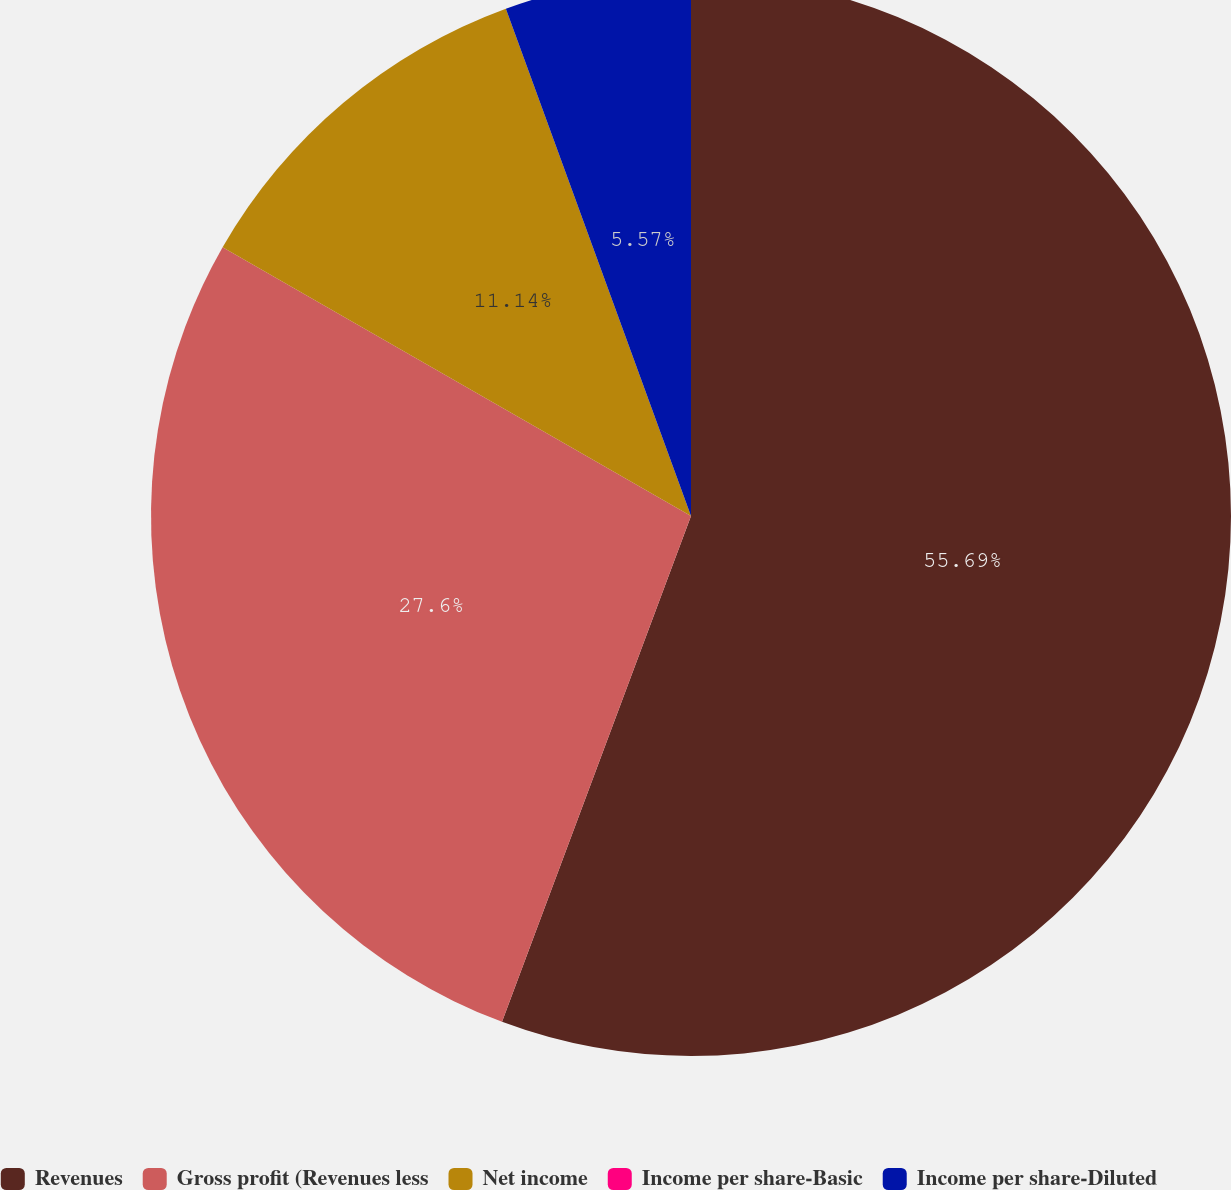Convert chart to OTSL. <chart><loc_0><loc_0><loc_500><loc_500><pie_chart><fcel>Revenues<fcel>Gross profit (Revenues less<fcel>Net income<fcel>Income per share-Basic<fcel>Income per share-Diluted<nl><fcel>55.69%<fcel>27.6%<fcel>11.14%<fcel>0.0%<fcel>5.57%<nl></chart> 